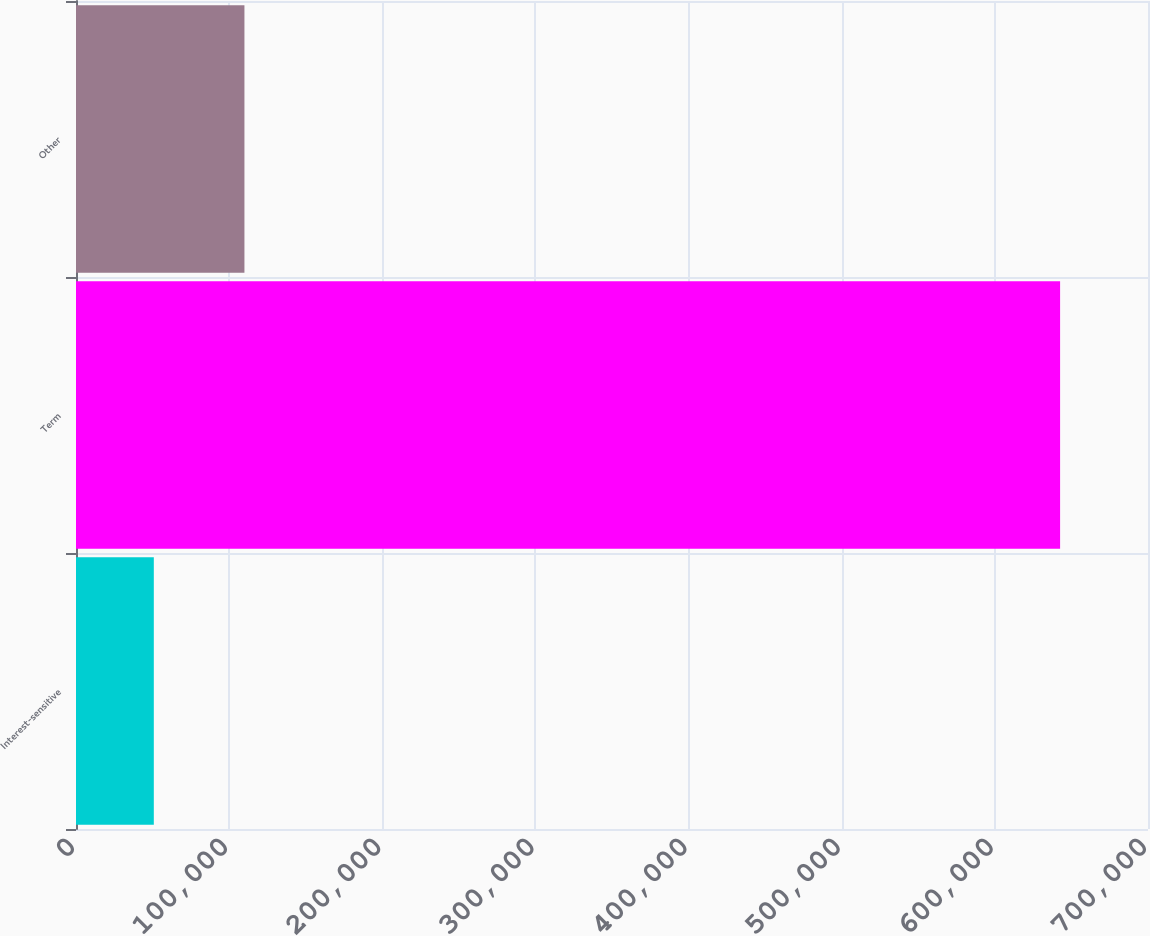Convert chart. <chart><loc_0><loc_0><loc_500><loc_500><bar_chart><fcel>Interest-sensitive<fcel>Term<fcel>Other<nl><fcel>50808<fcel>642599<fcel>109987<nl></chart> 